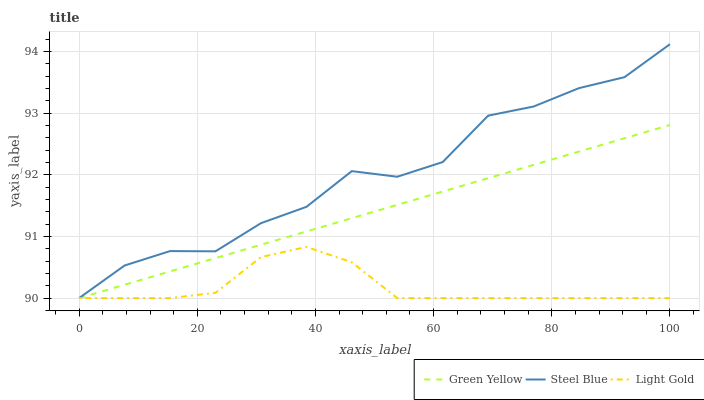Does Light Gold have the minimum area under the curve?
Answer yes or no. Yes. Does Steel Blue have the maximum area under the curve?
Answer yes or no. Yes. Does Steel Blue have the minimum area under the curve?
Answer yes or no. No. Does Light Gold have the maximum area under the curve?
Answer yes or no. No. Is Green Yellow the smoothest?
Answer yes or no. Yes. Is Steel Blue the roughest?
Answer yes or no. Yes. Is Light Gold the smoothest?
Answer yes or no. No. Is Light Gold the roughest?
Answer yes or no. No. Does Green Yellow have the lowest value?
Answer yes or no. Yes. Does Steel Blue have the highest value?
Answer yes or no. Yes. Does Light Gold have the highest value?
Answer yes or no. No. Does Steel Blue intersect Light Gold?
Answer yes or no. Yes. Is Steel Blue less than Light Gold?
Answer yes or no. No. Is Steel Blue greater than Light Gold?
Answer yes or no. No. 